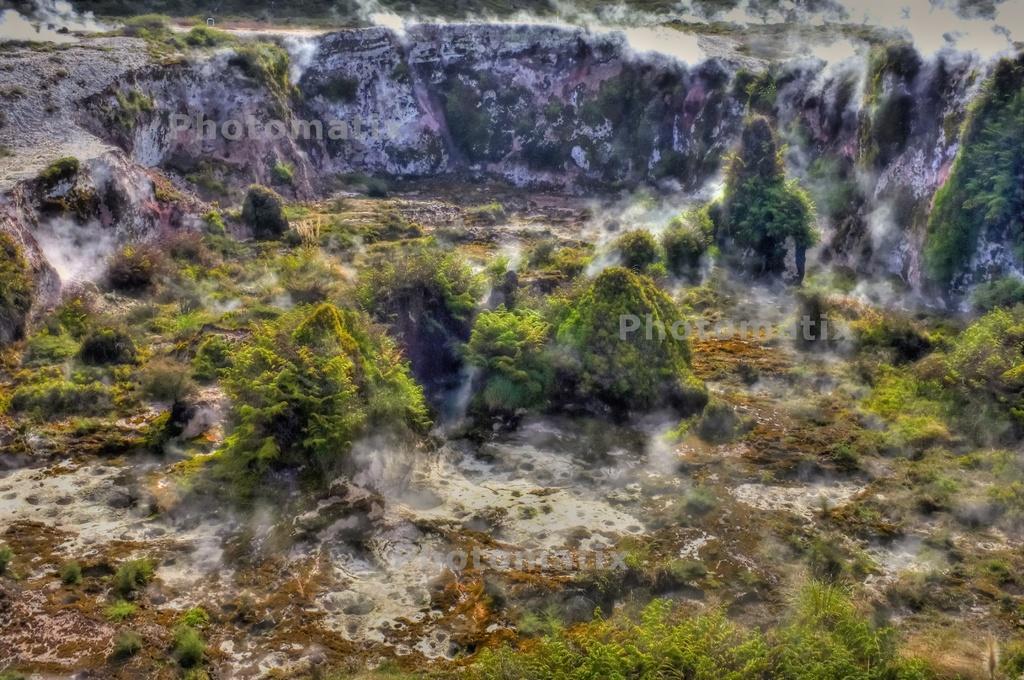Describe this image in one or two sentences. In this image we can see ground, trees and smoke. 